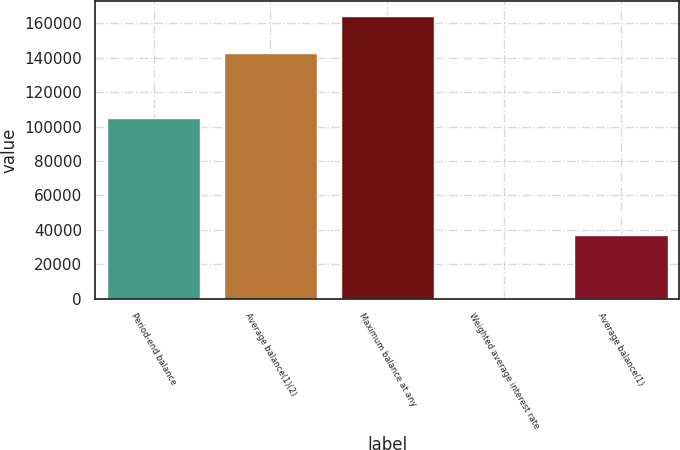Convert chart to OTSL. <chart><loc_0><loc_0><loc_500><loc_500><bar_chart><fcel>Period-end balance<fcel>Average balance(1)(2)<fcel>Maximum balance at any<fcel>Weighted average interest rate<fcel>Average balance(1)<nl><fcel>104800<fcel>142784<fcel>164511<fcel>0.8<fcel>36762<nl></chart> 